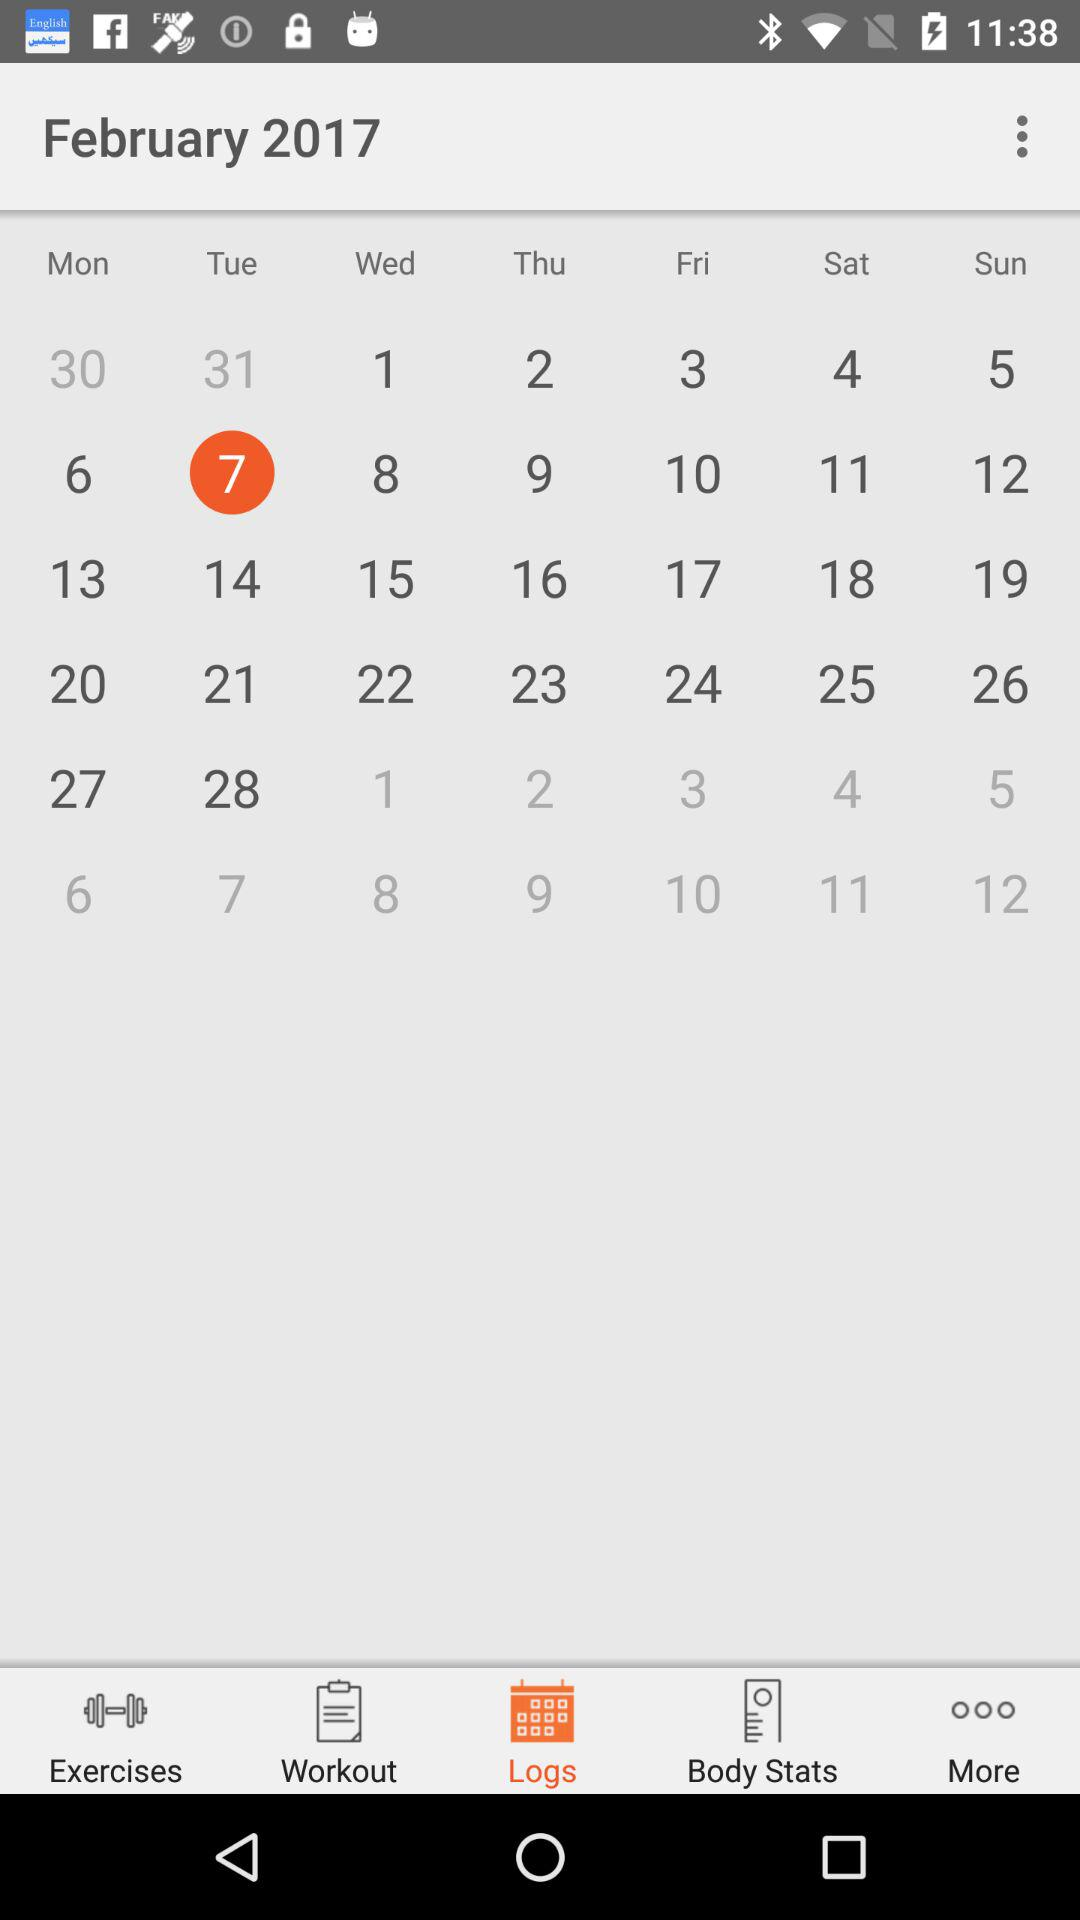What day falls on the selected date? On the selected date, the day is Tuesday. 